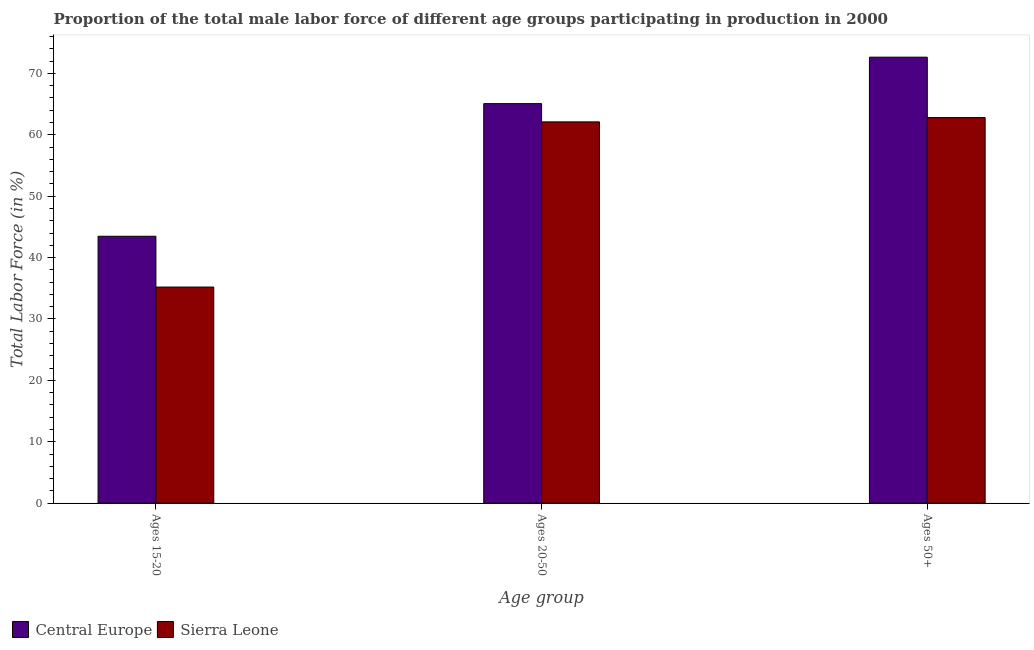How many groups of bars are there?
Your answer should be very brief. 3. Are the number of bars per tick equal to the number of legend labels?
Ensure brevity in your answer.  Yes. How many bars are there on the 1st tick from the left?
Give a very brief answer. 2. How many bars are there on the 1st tick from the right?
Make the answer very short. 2. What is the label of the 3rd group of bars from the left?
Offer a very short reply. Ages 50+. What is the percentage of male labor force above age 50 in Central Europe?
Ensure brevity in your answer.  72.64. Across all countries, what is the maximum percentage of male labor force within the age group 15-20?
Ensure brevity in your answer.  43.47. Across all countries, what is the minimum percentage of male labor force above age 50?
Provide a succinct answer. 62.8. In which country was the percentage of male labor force within the age group 20-50 maximum?
Your response must be concise. Central Europe. In which country was the percentage of male labor force within the age group 15-20 minimum?
Your answer should be compact. Sierra Leone. What is the total percentage of male labor force within the age group 15-20 in the graph?
Your answer should be very brief. 78.67. What is the difference between the percentage of male labor force within the age group 20-50 in Sierra Leone and that in Central Europe?
Give a very brief answer. -2.97. What is the difference between the percentage of male labor force within the age group 20-50 in Sierra Leone and the percentage of male labor force within the age group 15-20 in Central Europe?
Offer a very short reply. 18.63. What is the average percentage of male labor force within the age group 20-50 per country?
Offer a terse response. 63.59. What is the difference between the percentage of male labor force above age 50 and percentage of male labor force within the age group 15-20 in Central Europe?
Your answer should be compact. 29.17. In how many countries, is the percentage of male labor force within the age group 15-20 greater than 42 %?
Keep it short and to the point. 1. What is the ratio of the percentage of male labor force within the age group 15-20 in Central Europe to that in Sierra Leone?
Give a very brief answer. 1.24. Is the percentage of male labor force within the age group 20-50 in Central Europe less than that in Sierra Leone?
Ensure brevity in your answer.  No. Is the difference between the percentage of male labor force within the age group 20-50 in Sierra Leone and Central Europe greater than the difference between the percentage of male labor force above age 50 in Sierra Leone and Central Europe?
Offer a very short reply. Yes. What is the difference between the highest and the second highest percentage of male labor force within the age group 20-50?
Your response must be concise. 2.97. What is the difference between the highest and the lowest percentage of male labor force above age 50?
Offer a terse response. 9.84. In how many countries, is the percentage of male labor force above age 50 greater than the average percentage of male labor force above age 50 taken over all countries?
Offer a very short reply. 1. What does the 2nd bar from the left in Ages 50+ represents?
Offer a terse response. Sierra Leone. What does the 1st bar from the right in Ages 15-20 represents?
Ensure brevity in your answer.  Sierra Leone. How many bars are there?
Keep it short and to the point. 6. What is the difference between two consecutive major ticks on the Y-axis?
Keep it short and to the point. 10. How are the legend labels stacked?
Offer a very short reply. Horizontal. What is the title of the graph?
Keep it short and to the point. Proportion of the total male labor force of different age groups participating in production in 2000. Does "Azerbaijan" appear as one of the legend labels in the graph?
Your response must be concise. No. What is the label or title of the X-axis?
Make the answer very short. Age group. What is the label or title of the Y-axis?
Make the answer very short. Total Labor Force (in %). What is the Total Labor Force (in %) in Central Europe in Ages 15-20?
Give a very brief answer. 43.47. What is the Total Labor Force (in %) of Sierra Leone in Ages 15-20?
Ensure brevity in your answer.  35.2. What is the Total Labor Force (in %) of Central Europe in Ages 20-50?
Give a very brief answer. 65.07. What is the Total Labor Force (in %) of Sierra Leone in Ages 20-50?
Provide a succinct answer. 62.1. What is the Total Labor Force (in %) of Central Europe in Ages 50+?
Ensure brevity in your answer.  72.64. What is the Total Labor Force (in %) in Sierra Leone in Ages 50+?
Your response must be concise. 62.8. Across all Age group, what is the maximum Total Labor Force (in %) in Central Europe?
Keep it short and to the point. 72.64. Across all Age group, what is the maximum Total Labor Force (in %) of Sierra Leone?
Provide a succinct answer. 62.8. Across all Age group, what is the minimum Total Labor Force (in %) of Central Europe?
Give a very brief answer. 43.47. Across all Age group, what is the minimum Total Labor Force (in %) of Sierra Leone?
Your answer should be very brief. 35.2. What is the total Total Labor Force (in %) of Central Europe in the graph?
Provide a succinct answer. 181.18. What is the total Total Labor Force (in %) in Sierra Leone in the graph?
Ensure brevity in your answer.  160.1. What is the difference between the Total Labor Force (in %) of Central Europe in Ages 15-20 and that in Ages 20-50?
Offer a terse response. -21.6. What is the difference between the Total Labor Force (in %) in Sierra Leone in Ages 15-20 and that in Ages 20-50?
Give a very brief answer. -26.9. What is the difference between the Total Labor Force (in %) in Central Europe in Ages 15-20 and that in Ages 50+?
Offer a very short reply. -29.17. What is the difference between the Total Labor Force (in %) of Sierra Leone in Ages 15-20 and that in Ages 50+?
Provide a short and direct response. -27.6. What is the difference between the Total Labor Force (in %) in Central Europe in Ages 20-50 and that in Ages 50+?
Ensure brevity in your answer.  -7.57. What is the difference between the Total Labor Force (in %) of Sierra Leone in Ages 20-50 and that in Ages 50+?
Make the answer very short. -0.7. What is the difference between the Total Labor Force (in %) in Central Europe in Ages 15-20 and the Total Labor Force (in %) in Sierra Leone in Ages 20-50?
Keep it short and to the point. -18.63. What is the difference between the Total Labor Force (in %) in Central Europe in Ages 15-20 and the Total Labor Force (in %) in Sierra Leone in Ages 50+?
Keep it short and to the point. -19.33. What is the difference between the Total Labor Force (in %) of Central Europe in Ages 20-50 and the Total Labor Force (in %) of Sierra Leone in Ages 50+?
Ensure brevity in your answer.  2.27. What is the average Total Labor Force (in %) of Central Europe per Age group?
Offer a terse response. 60.39. What is the average Total Labor Force (in %) of Sierra Leone per Age group?
Provide a short and direct response. 53.37. What is the difference between the Total Labor Force (in %) in Central Europe and Total Labor Force (in %) in Sierra Leone in Ages 15-20?
Keep it short and to the point. 8.27. What is the difference between the Total Labor Force (in %) in Central Europe and Total Labor Force (in %) in Sierra Leone in Ages 20-50?
Provide a succinct answer. 2.97. What is the difference between the Total Labor Force (in %) of Central Europe and Total Labor Force (in %) of Sierra Leone in Ages 50+?
Your response must be concise. 9.84. What is the ratio of the Total Labor Force (in %) in Central Europe in Ages 15-20 to that in Ages 20-50?
Offer a terse response. 0.67. What is the ratio of the Total Labor Force (in %) in Sierra Leone in Ages 15-20 to that in Ages 20-50?
Offer a very short reply. 0.57. What is the ratio of the Total Labor Force (in %) of Central Europe in Ages 15-20 to that in Ages 50+?
Ensure brevity in your answer.  0.6. What is the ratio of the Total Labor Force (in %) of Sierra Leone in Ages 15-20 to that in Ages 50+?
Offer a terse response. 0.56. What is the ratio of the Total Labor Force (in %) of Central Europe in Ages 20-50 to that in Ages 50+?
Provide a succinct answer. 0.9. What is the ratio of the Total Labor Force (in %) of Sierra Leone in Ages 20-50 to that in Ages 50+?
Provide a short and direct response. 0.99. What is the difference between the highest and the second highest Total Labor Force (in %) of Central Europe?
Give a very brief answer. 7.57. What is the difference between the highest and the lowest Total Labor Force (in %) in Central Europe?
Provide a succinct answer. 29.17. What is the difference between the highest and the lowest Total Labor Force (in %) in Sierra Leone?
Your response must be concise. 27.6. 